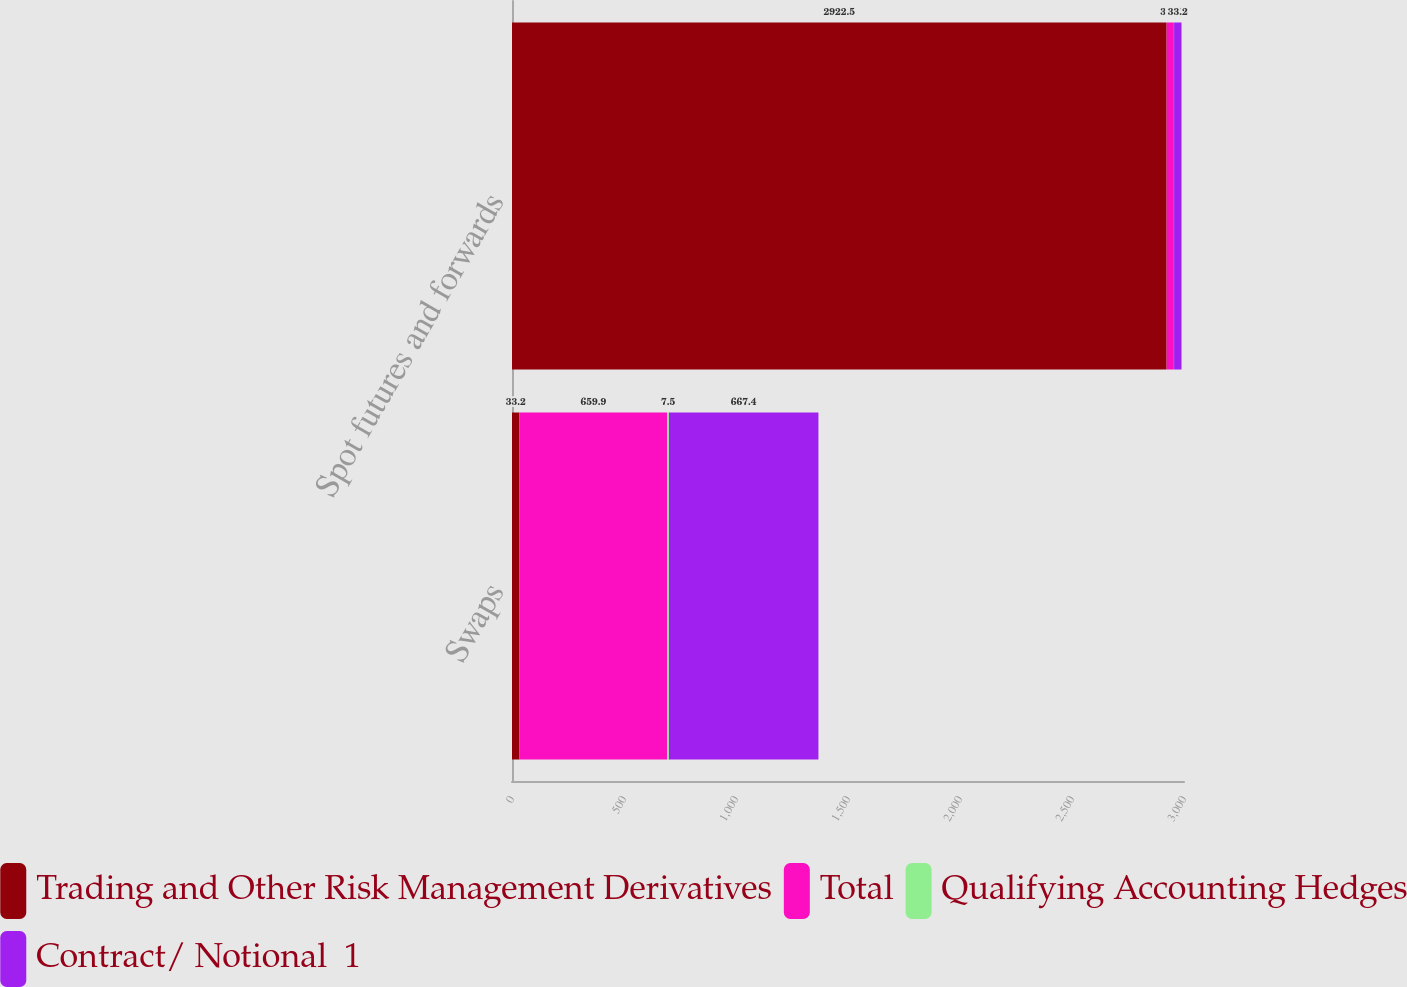Convert chart. <chart><loc_0><loc_0><loc_500><loc_500><stacked_bar_chart><ecel><fcel>Swaps<fcel>Spot futures and forwards<nl><fcel>Trading and Other Risk Management Derivatives<fcel>33.2<fcel>2922.5<nl><fcel>Total<fcel>659.9<fcel>32.5<nl><fcel>Qualifying Accounting Hedges<fcel>7.5<fcel>0.7<nl><fcel>Contract/ Notional  1<fcel>667.4<fcel>33.2<nl></chart> 